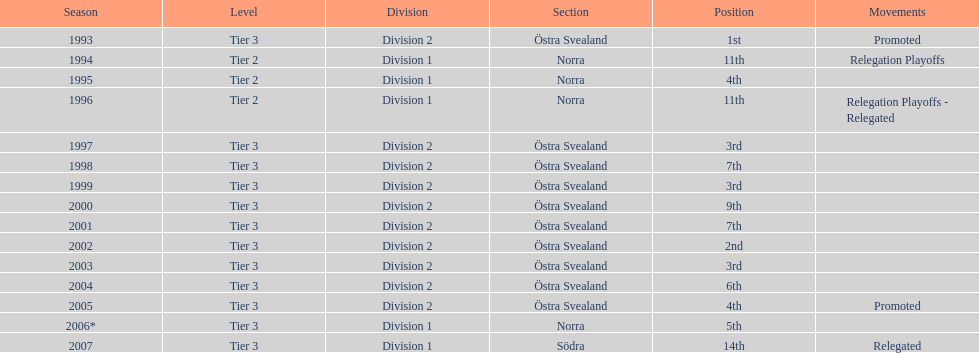What is the only year with the 1st position? 1993. 